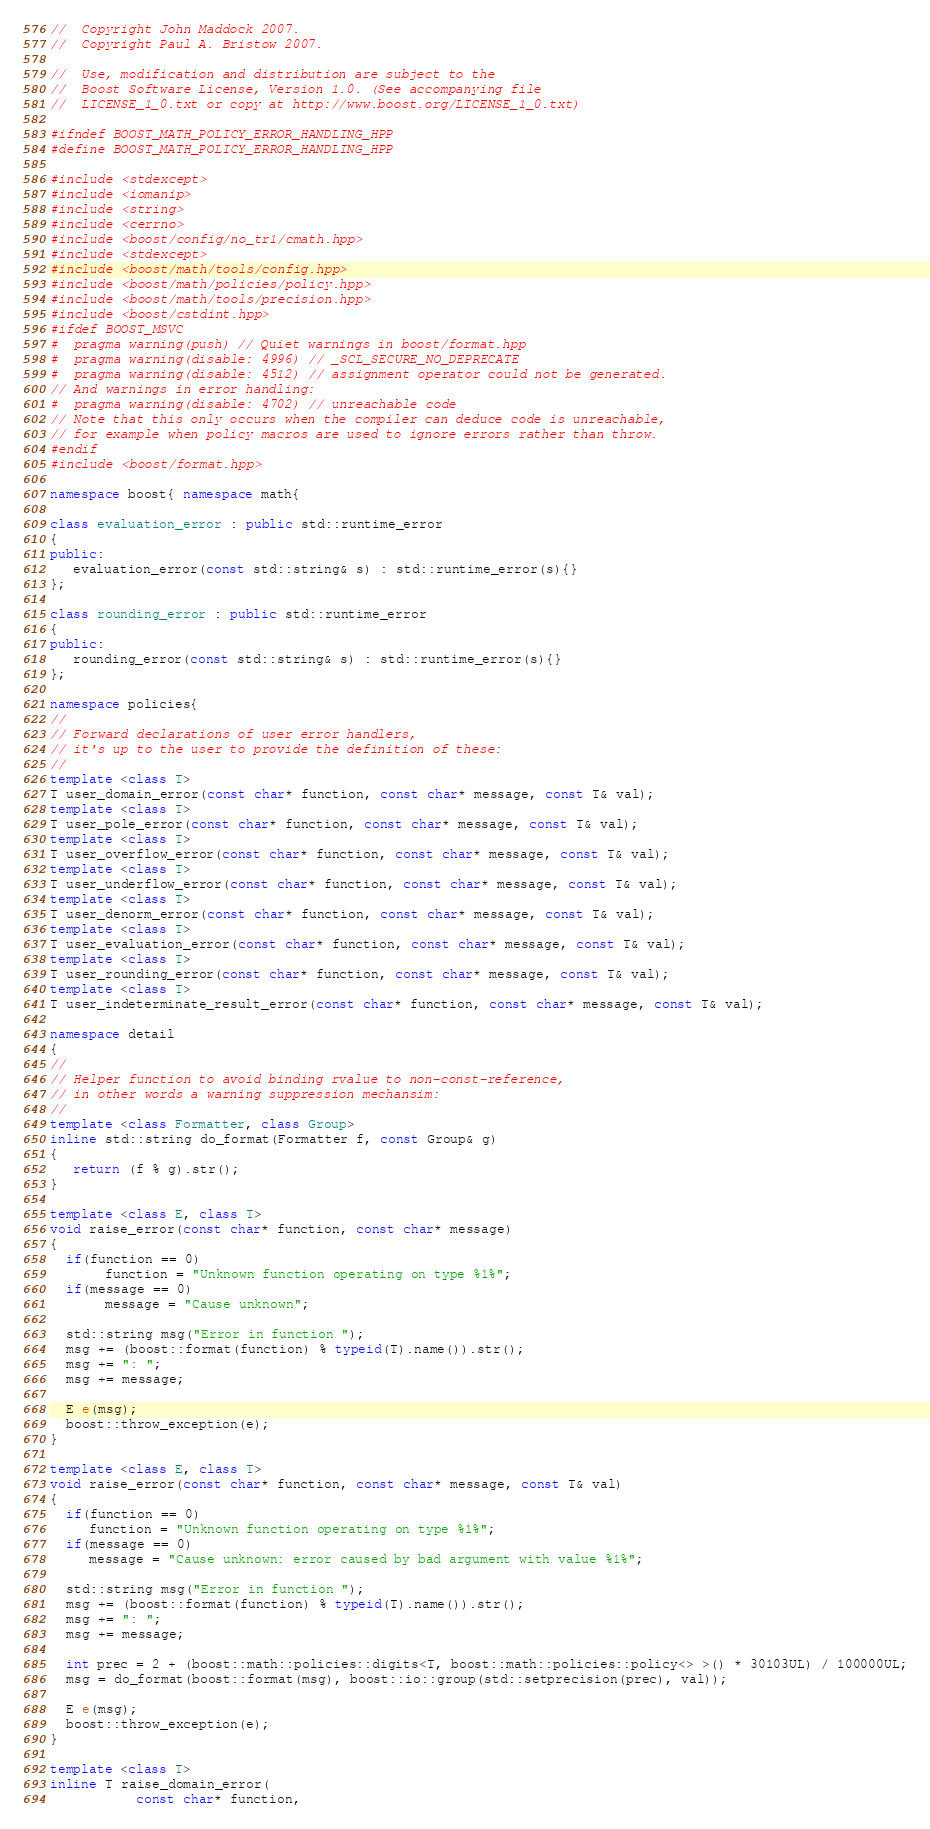Convert code to text. <code><loc_0><loc_0><loc_500><loc_500><_C++_>//  Copyright John Maddock 2007.
//  Copyright Paul A. Bristow 2007.

//  Use, modification and distribution are subject to the
//  Boost Software License, Version 1.0. (See accompanying file
//  LICENSE_1_0.txt or copy at http://www.boost.org/LICENSE_1_0.txt)

#ifndef BOOST_MATH_POLICY_ERROR_HANDLING_HPP
#define BOOST_MATH_POLICY_ERROR_HANDLING_HPP

#include <stdexcept>
#include <iomanip>
#include <string>
#include <cerrno>
#include <boost/config/no_tr1/cmath.hpp>
#include <stdexcept>
#include <boost/math/tools/config.hpp>
#include <boost/math/policies/policy.hpp>
#include <boost/math/tools/precision.hpp>
#include <boost/cstdint.hpp>
#ifdef BOOST_MSVC
#  pragma warning(push) // Quiet warnings in boost/format.hpp
#  pragma warning(disable: 4996) // _SCL_SECURE_NO_DEPRECATE
#  pragma warning(disable: 4512) // assignment operator could not be generated.
// And warnings in error handling:
#  pragma warning(disable: 4702) // unreachable code
// Note that this only occurs when the compiler can deduce code is unreachable,
// for example when policy macros are used to ignore errors rather than throw.
#endif
#include <boost/format.hpp>

namespace boost{ namespace math{

class evaluation_error : public std::runtime_error
{
public:
   evaluation_error(const std::string& s) : std::runtime_error(s){}
};

class rounding_error : public std::runtime_error
{
public:
   rounding_error(const std::string& s) : std::runtime_error(s){}
};

namespace policies{
//
// Forward declarations of user error handlers, 
// it's up to the user to provide the definition of these:
//
template <class T>
T user_domain_error(const char* function, const char* message, const T& val);
template <class T>
T user_pole_error(const char* function, const char* message, const T& val);
template <class T>
T user_overflow_error(const char* function, const char* message, const T& val);
template <class T>
T user_underflow_error(const char* function, const char* message, const T& val);
template <class T>
T user_denorm_error(const char* function, const char* message, const T& val);
template <class T>
T user_evaluation_error(const char* function, const char* message, const T& val);
template <class T>
T user_rounding_error(const char* function, const char* message, const T& val);
template <class T>
T user_indeterminate_result_error(const char* function, const char* message, const T& val);

namespace detail
{
//
// Helper function to avoid binding rvalue to non-const-reference,
// in other words a warning suppression mechansim:
//
template <class Formatter, class Group>
inline std::string do_format(Formatter f, const Group& g)
{
   return (f % g).str();
}

template <class E, class T>
void raise_error(const char* function, const char* message)
{
  if(function == 0)
       function = "Unknown function operating on type %1%";
  if(message == 0)
       message = "Cause unknown";

  std::string msg("Error in function ");
  msg += (boost::format(function) % typeid(T).name()).str();
  msg += ": ";
  msg += message;

  E e(msg);
  boost::throw_exception(e);
}

template <class E, class T>
void raise_error(const char* function, const char* message, const T& val)
{
  if(function == 0)
     function = "Unknown function operating on type %1%";
  if(message == 0)
     message = "Cause unknown: error caused by bad argument with value %1%";

  std::string msg("Error in function ");
  msg += (boost::format(function) % typeid(T).name()).str();
  msg += ": ";
  msg += message;

  int prec = 2 + (boost::math::policies::digits<T, boost::math::policies::policy<> >() * 30103UL) / 100000UL;
  msg = do_format(boost::format(msg), boost::io::group(std::setprecision(prec), val));

  E e(msg);
  boost::throw_exception(e);
}

template <class T>
inline T raise_domain_error(
           const char* function, </code> 